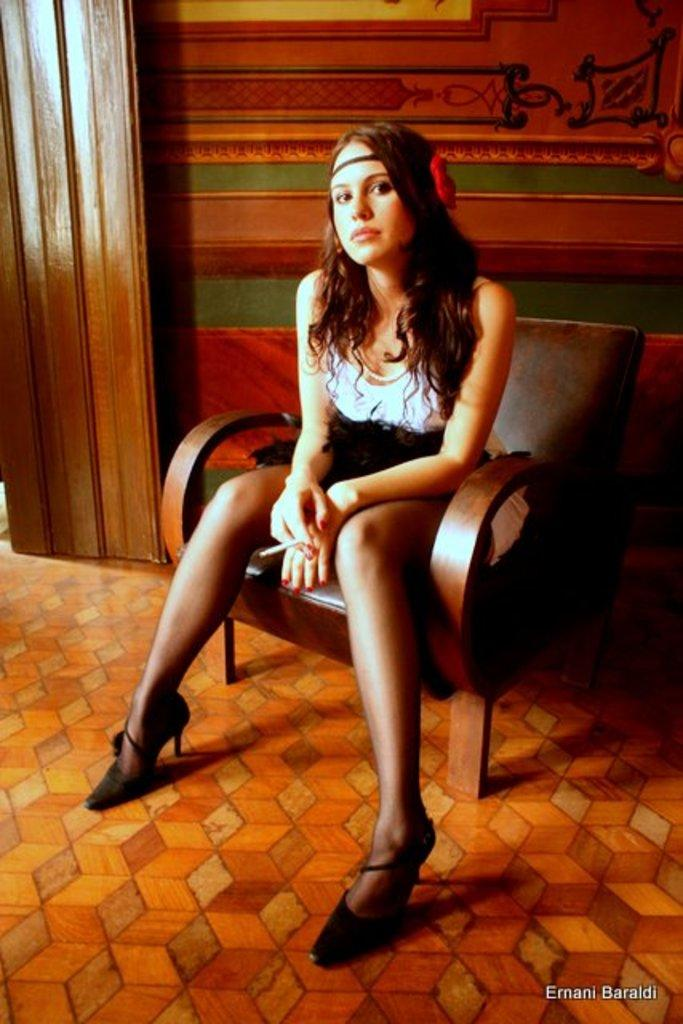Who is present in the image? There are women in the picture. What colors are the dresses of the women in the image? The women are wearing white and black color dresses. What are the women doing in the image? The women are sitting on a chair. What can be seen in the background of the picture? There is a wall in the background of the picture. Where is the sink located in the image? There is no sink present in the image. What type of field can be seen in the background of the image? There is no field visible in the background of the image; it features a wall. 